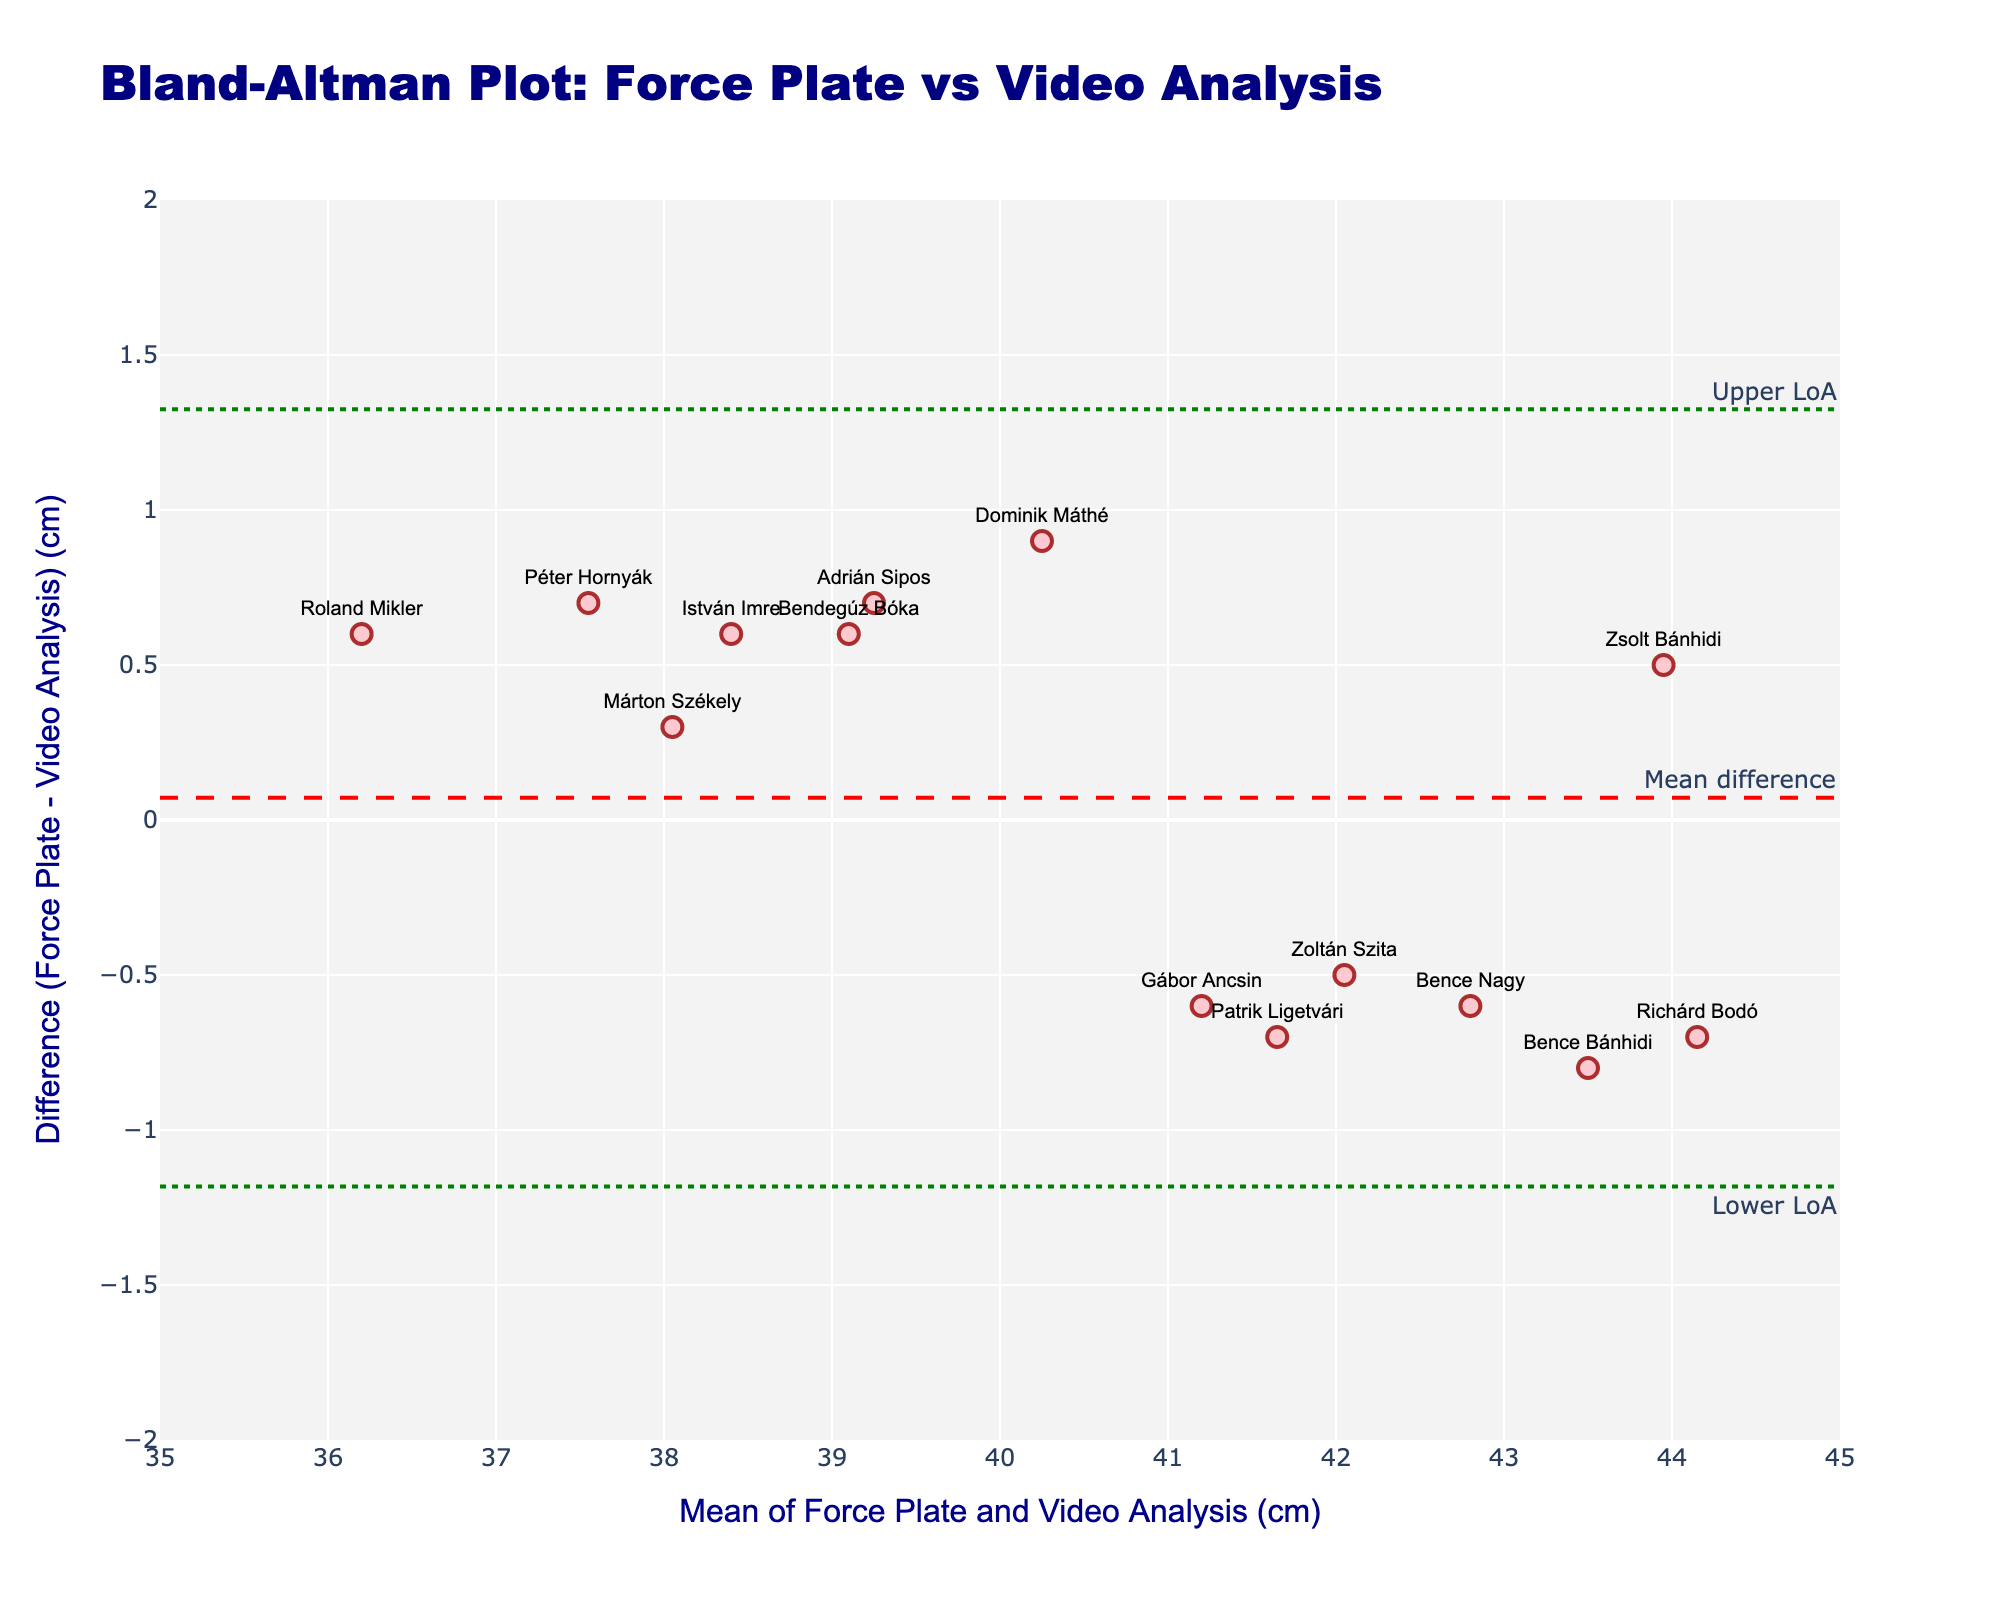What's the title of the plot? The title is located at the top of the plot and helps to understand what the visual is about. It says "Bland-Altman Plot: Force Plate vs Video Analysis".
Answer: Bland-Altman Plot: Force Plate vs Video Analysis What is the x-axis title? The x-axis title is found below the horizontal axis and indicates the meaning of the values on this axis. It reads "Mean of Force Plate and Video Analysis (cm)".
Answer: Mean of Force Plate and Video Analysis (cm) How many data points are depicted in the plot? Count each marker (data point) plotted on the Bland-Altman plot. There are 14 markers, each representing a different handball athlete.
Answer: 14 What does the red dashed line represent? The red dashed line is labeled "Mean difference" and represents the average difference in jump height measurements between the Force Plate and Video Analysis methods.
Answer: Mean difference What are the values of the upper and lower limits of agreement (LoA)? Identify the green dotted lines, annotation text on the right indicates "Upper LoA" and "Lower LoA". Estimate where these lines intersect the y-axis. The upper LoA is around 1.2 and the lower LoA is around -1.2.
Answer: Upper: ~1.2, Lower: ~-1.2 Which player shows the largest positive difference between the two methods? Look for the marker that is farthest above the zero line. "István Imre" shows the largest positive difference.
Answer: István Imre Is the difference between the two methods more often positive or negative? Examine the number of points above and below the zero line (y=0). More points are above the zero line, indicating that the difference is more often positive.
Answer: Positive Which player has the smallest mean value of jump height measurement? Identify the lowest marker on the x-axis, which corresponds to the player "Roland Mikler" with a mean value of about 36.2 cm.
Answer: Roland Mikler What is the general trend indicated by the data points in relation to the zero difference line? Observe if the points cluster around or deviate systematically from the zero line. The points are spread without systematic clustering, showing no consistent trend.
Answer: No consistent trend What is the mean difference in height measurements between the two methods? The mean difference is indicated by the red dashed line intersecting the y-axis, its value is provided on the annotation as "Mean difference". It is approximately 0.04 cm.
Answer: 0.04 cm 